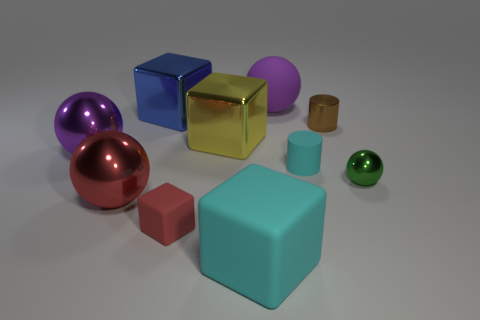Subtract 1 balls. How many balls are left? 3 Subtract all spheres. How many objects are left? 6 Subtract all cylinders. Subtract all matte spheres. How many objects are left? 7 Add 9 small cyan cylinders. How many small cyan cylinders are left? 10 Add 5 big blue metal things. How many big blue metal things exist? 6 Subtract 1 blue blocks. How many objects are left? 9 